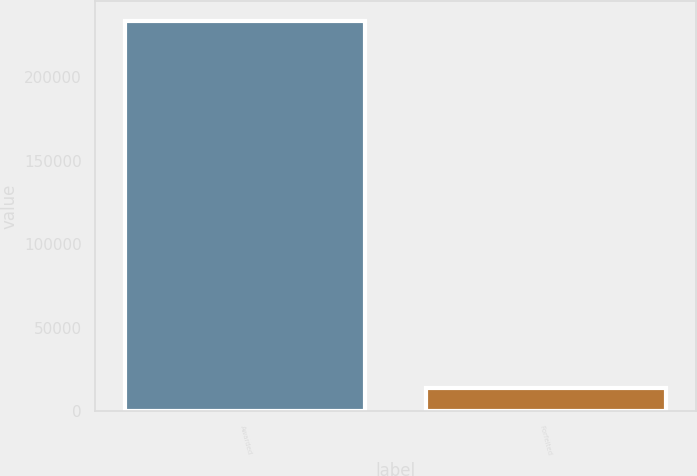<chart> <loc_0><loc_0><loc_500><loc_500><bar_chart><fcel>Awarded<fcel>Forfeited<nl><fcel>233939<fcel>13791<nl></chart> 